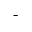<formula> <loc_0><loc_0><loc_500><loc_500>^ { - }</formula> 